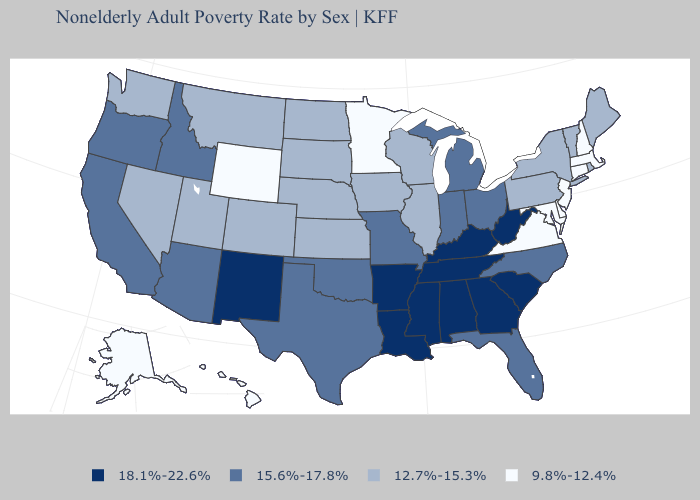Name the states that have a value in the range 12.7%-15.3%?
Keep it brief. Colorado, Illinois, Iowa, Kansas, Maine, Montana, Nebraska, Nevada, New York, North Dakota, Pennsylvania, Rhode Island, South Dakota, Utah, Vermont, Washington, Wisconsin. Does New Mexico have the same value as Massachusetts?
Short answer required. No. Does the map have missing data?
Keep it brief. No. What is the highest value in the USA?
Be succinct. 18.1%-22.6%. Name the states that have a value in the range 18.1%-22.6%?
Short answer required. Alabama, Arkansas, Georgia, Kentucky, Louisiana, Mississippi, New Mexico, South Carolina, Tennessee, West Virginia. Among the states that border Massachusetts , which have the lowest value?
Short answer required. Connecticut, New Hampshire. Among the states that border California , does Nevada have the lowest value?
Short answer required. Yes. Among the states that border Illinois , which have the highest value?
Quick response, please. Kentucky. What is the value of Idaho?
Short answer required. 15.6%-17.8%. Name the states that have a value in the range 18.1%-22.6%?
Quick response, please. Alabama, Arkansas, Georgia, Kentucky, Louisiana, Mississippi, New Mexico, South Carolina, Tennessee, West Virginia. Name the states that have a value in the range 18.1%-22.6%?
Write a very short answer. Alabama, Arkansas, Georgia, Kentucky, Louisiana, Mississippi, New Mexico, South Carolina, Tennessee, West Virginia. Name the states that have a value in the range 18.1%-22.6%?
Keep it brief. Alabama, Arkansas, Georgia, Kentucky, Louisiana, Mississippi, New Mexico, South Carolina, Tennessee, West Virginia. Which states have the highest value in the USA?
Be succinct. Alabama, Arkansas, Georgia, Kentucky, Louisiana, Mississippi, New Mexico, South Carolina, Tennessee, West Virginia. Name the states that have a value in the range 9.8%-12.4%?
Keep it brief. Alaska, Connecticut, Delaware, Hawaii, Maryland, Massachusetts, Minnesota, New Hampshire, New Jersey, Virginia, Wyoming. Does Nebraska have a higher value than New Jersey?
Concise answer only. Yes. 